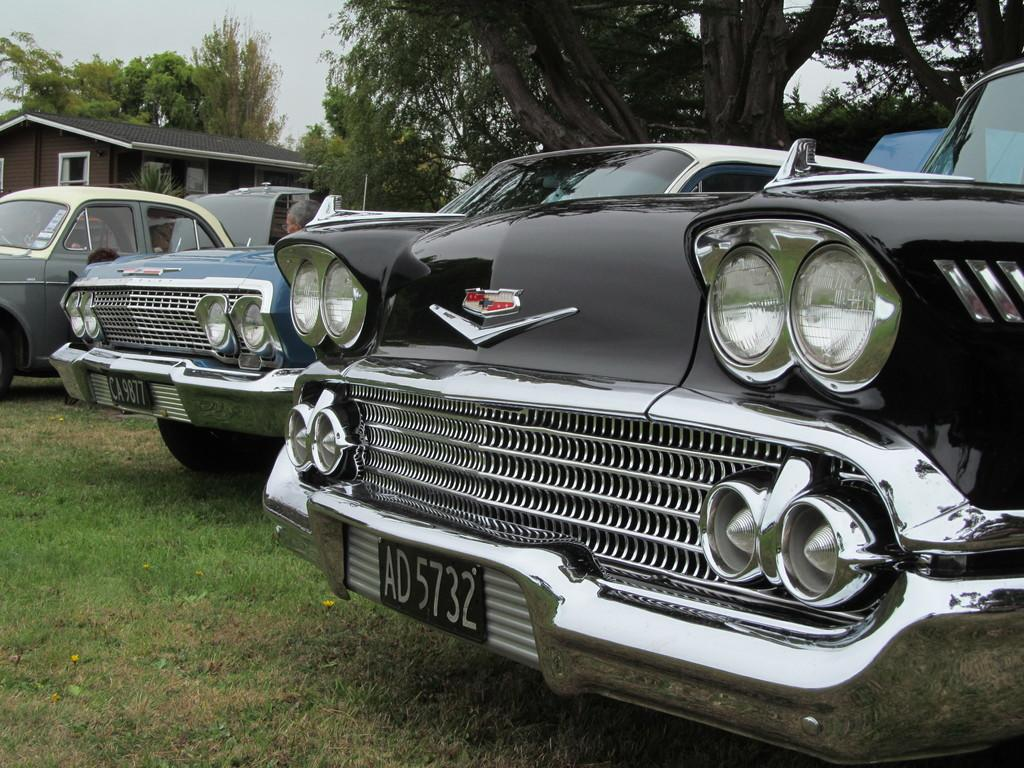What type of vehicles can be seen on the grassland in the image? There are vehicles on the grassland in the image. What structure is located on the left side of the image? There is a house on the left side of the image. What can be seen in the background of the image? There are trees in the background of the image. What is visible at the top left of the image? The sky is visible at the top left of the image. What type of team is playing in the sand in the image? There is no team playing in the sand in the image; it features vehicles on grassland, a house, trees, and the sky. What offer is being made by the house in the image? There is no offer being made by the house in the image; it is a stationary structure. 